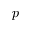Convert formula to latex. <formula><loc_0><loc_0><loc_500><loc_500>p</formula> 